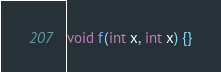Convert code to text. <code><loc_0><loc_0><loc_500><loc_500><_C_>void f(int x, int x) {}
</code> 